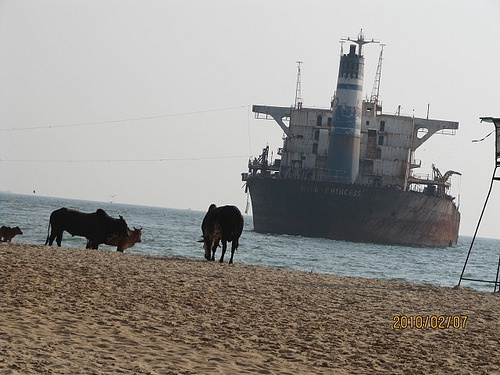Describe the objects in this image and their specific colors. I can see boat in lightgray, gray, and black tones, cow in lightgray, black, gray, darkgray, and purple tones, cow in lightgray, black, gray, and darkgray tones, horse in lightgray, black, gray, and darkgray tones, and cow in lightgray, black, gray, maroon, and darkgray tones in this image. 